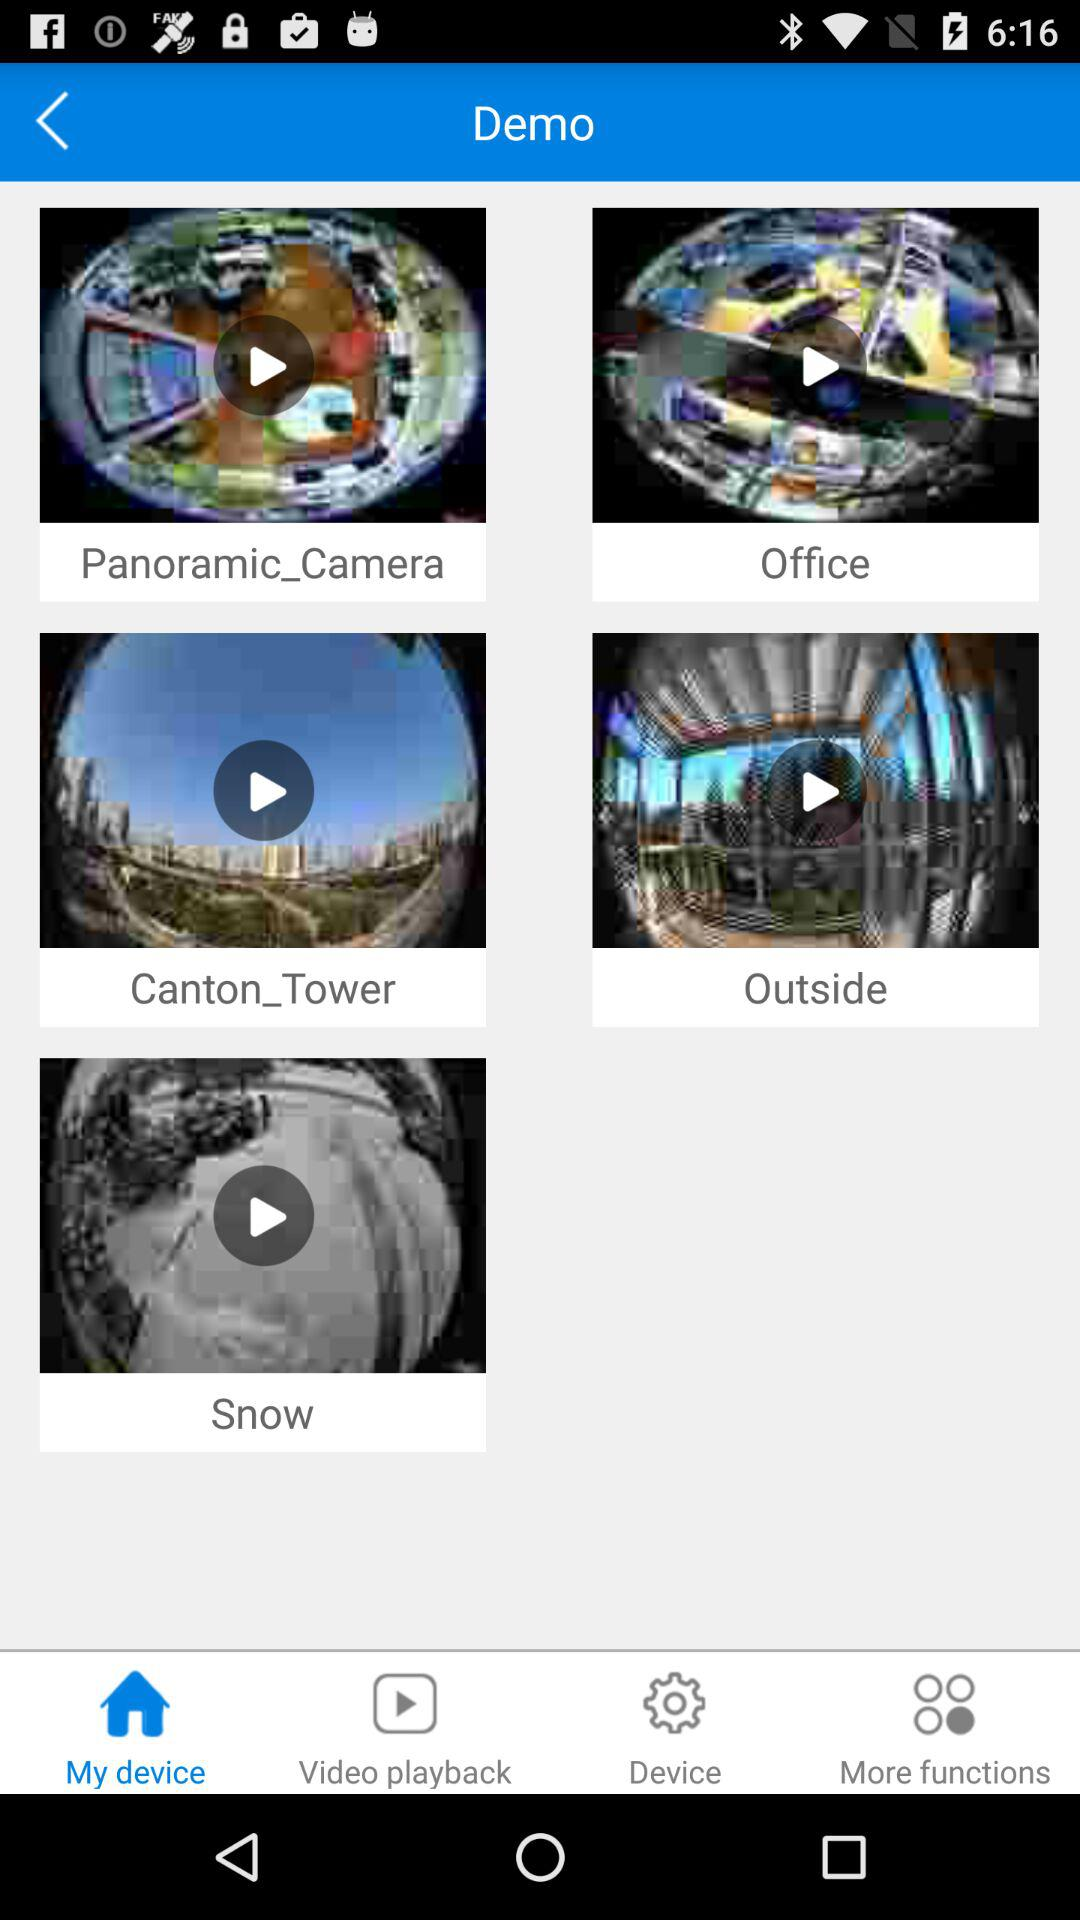Which device is connected?
When the provided information is insufficient, respond with <no answer>. <no answer> 